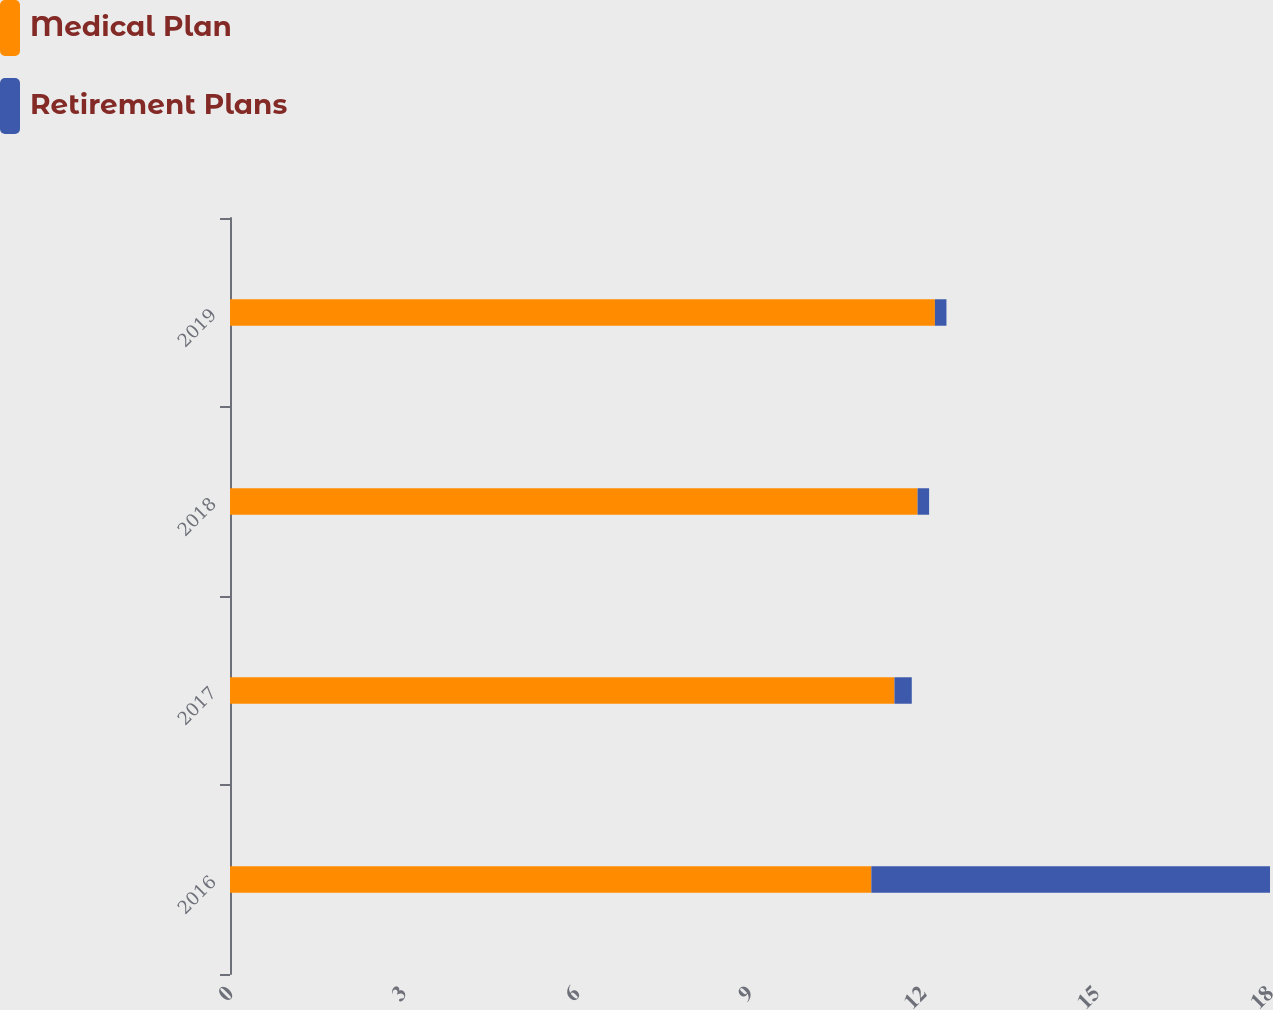<chart> <loc_0><loc_0><loc_500><loc_500><stacked_bar_chart><ecel><fcel>2016<fcel>2017<fcel>2018<fcel>2019<nl><fcel>Medical Plan<fcel>11.1<fcel>11.5<fcel>11.9<fcel>12.2<nl><fcel>Retirement Plans<fcel>6.9<fcel>0.3<fcel>0.2<fcel>0.2<nl></chart> 